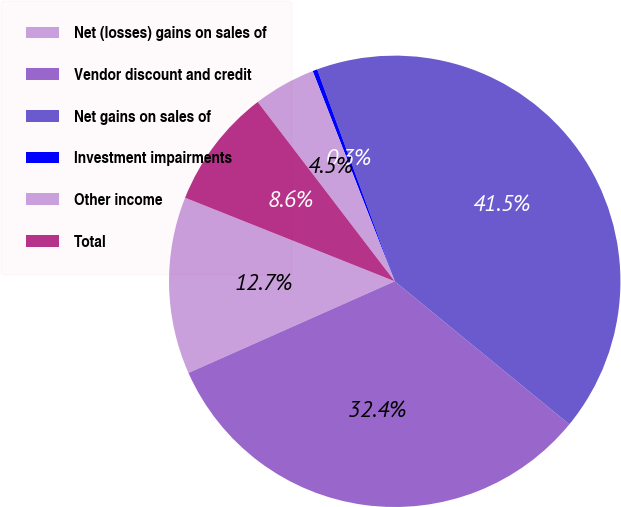Convert chart to OTSL. <chart><loc_0><loc_0><loc_500><loc_500><pie_chart><fcel>Net (losses) gains on sales of<fcel>Vendor discount and credit<fcel>Net gains on sales of<fcel>Investment impairments<fcel>Other income<fcel>Total<nl><fcel>12.69%<fcel>32.42%<fcel>41.5%<fcel>0.34%<fcel>4.46%<fcel>8.58%<nl></chart> 